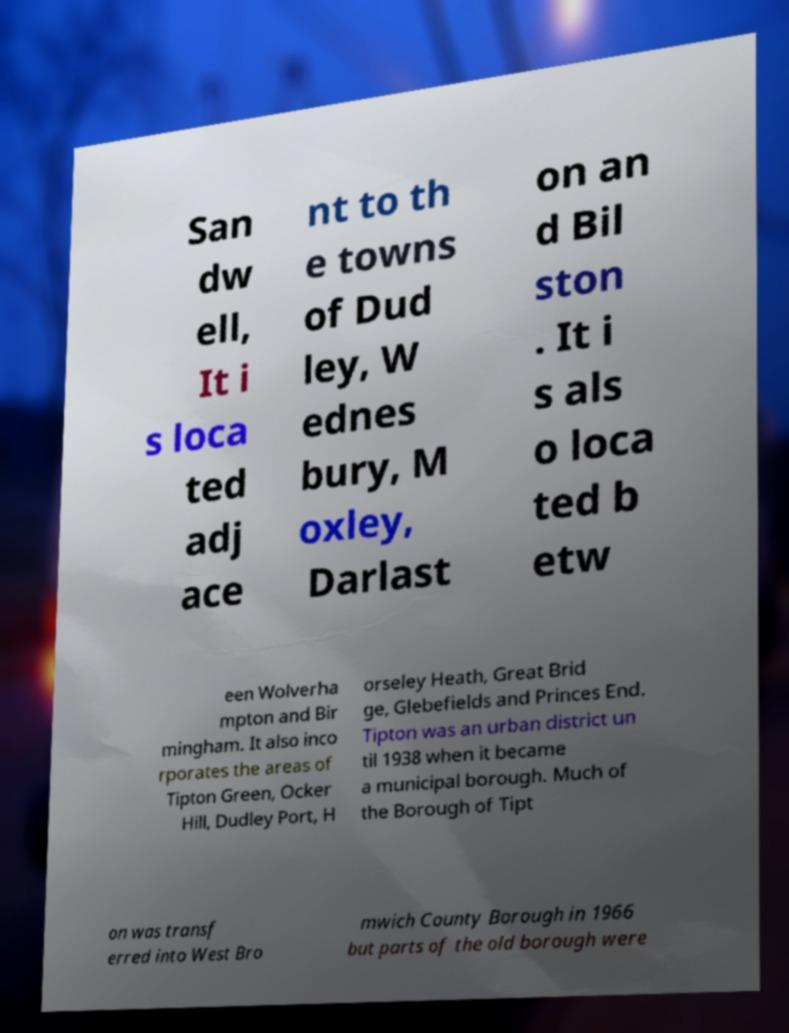What messages or text are displayed in this image? I need them in a readable, typed format. San dw ell, It i s loca ted adj ace nt to th e towns of Dud ley, W ednes bury, M oxley, Darlast on an d Bil ston . It i s als o loca ted b etw een Wolverha mpton and Bir mingham. It also inco rporates the areas of Tipton Green, Ocker Hill, Dudley Port, H orseley Heath, Great Brid ge, Glebefields and Princes End. Tipton was an urban district un til 1938 when it became a municipal borough. Much of the Borough of Tipt on was transf erred into West Bro mwich County Borough in 1966 but parts of the old borough were 